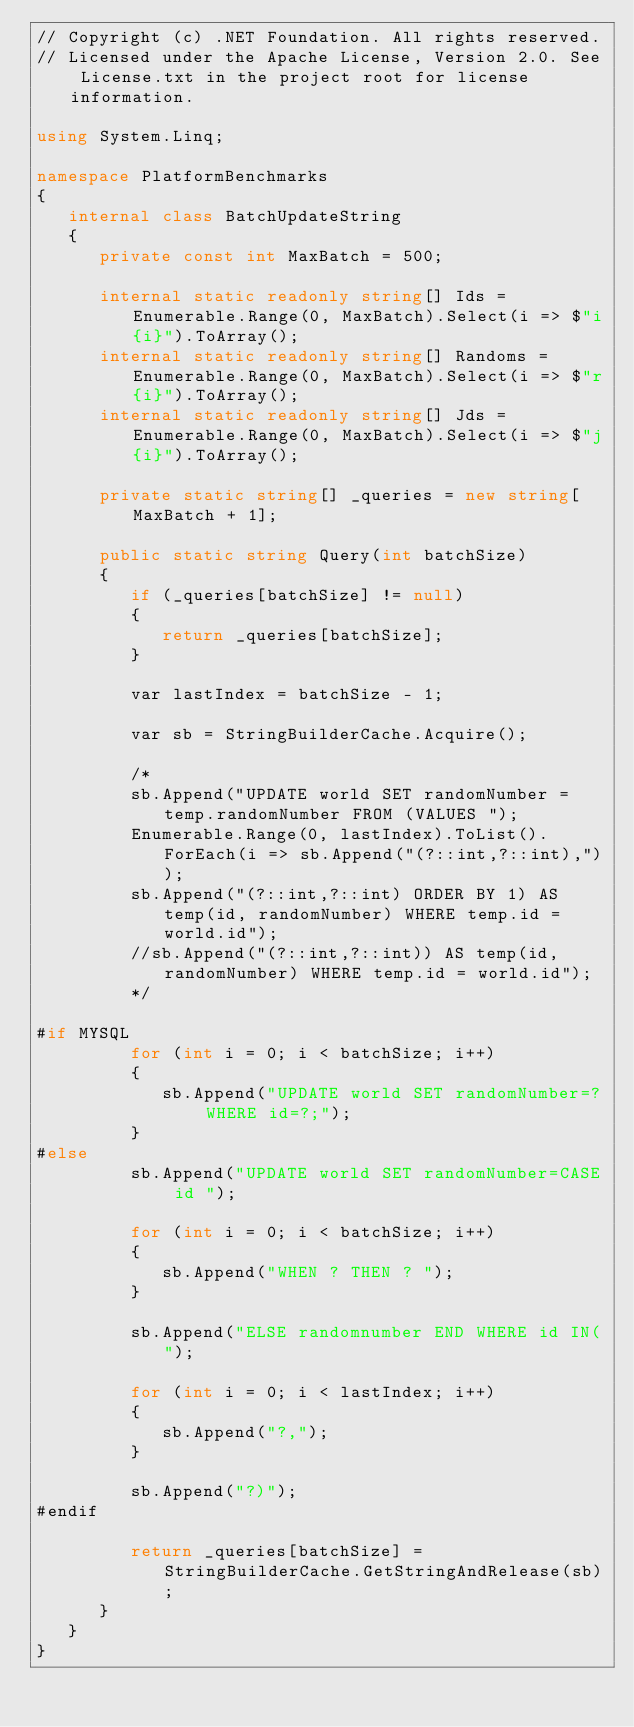Convert code to text. <code><loc_0><loc_0><loc_500><loc_500><_C#_>// Copyright (c) .NET Foundation. All rights reserved. 
// Licensed under the Apache License, Version 2.0. See License.txt in the project root for license information. 

using System.Linq;

namespace PlatformBenchmarks
{
   internal class BatchUpdateString
   {
      private const int MaxBatch = 500;

      internal static readonly string[] Ids = Enumerable.Range(0, MaxBatch).Select(i => $"i{i}").ToArray();
      internal static readonly string[] Randoms = Enumerable.Range(0, MaxBatch).Select(i => $"r{i}").ToArray();
      internal static readonly string[] Jds = Enumerable.Range(0, MaxBatch).Select(i => $"j{i}").ToArray();

      private static string[] _queries = new string[MaxBatch + 1];

      public static string Query(int batchSize)
      {
         if (_queries[batchSize] != null)
         {
            return _queries[batchSize];
         }

         var lastIndex = batchSize - 1;

         var sb = StringBuilderCache.Acquire();

         /*
         sb.Append("UPDATE world SET randomNumber = temp.randomNumber FROM (VALUES ");
         Enumerable.Range(0, lastIndex).ToList().ForEach(i => sb.Append("(?::int,?::int),"));
         sb.Append("(?::int,?::int) ORDER BY 1) AS temp(id, randomNumber) WHERE temp.id = world.id");
         //sb.Append("(?::int,?::int)) AS temp(id, randomNumber) WHERE temp.id = world.id");
         */

#if MYSQL
         for (int i = 0; i < batchSize; i++)
         {
            sb.Append("UPDATE world SET randomNumber=? WHERE id=?;");
         }
#else
         sb.Append("UPDATE world SET randomNumber=CASE id ");

         for (int i = 0; i < batchSize; i++)
         {
            sb.Append("WHEN ? THEN ? ");
         }

         sb.Append("ELSE randomnumber END WHERE id IN(");

         for (int i = 0; i < lastIndex; i++)
         {
            sb.Append("?,");
         }

         sb.Append("?)");
#endif

         return _queries[batchSize] = StringBuilderCache.GetStringAndRelease(sb);
      }
   }
}</code> 